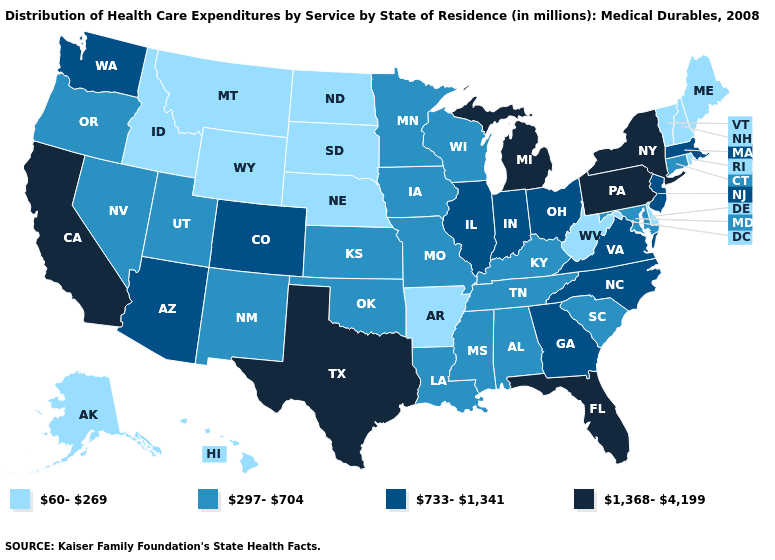Which states have the lowest value in the South?
Be succinct. Arkansas, Delaware, West Virginia. Name the states that have a value in the range 297-704?
Short answer required. Alabama, Connecticut, Iowa, Kansas, Kentucky, Louisiana, Maryland, Minnesota, Mississippi, Missouri, Nevada, New Mexico, Oklahoma, Oregon, South Carolina, Tennessee, Utah, Wisconsin. What is the value of Virginia?
Give a very brief answer. 733-1,341. Does Rhode Island have the same value as Connecticut?
Short answer required. No. Which states hav the highest value in the MidWest?
Write a very short answer. Michigan. Does Georgia have the lowest value in the South?
Be succinct. No. Among the states that border Missouri , does Tennessee have the highest value?
Quick response, please. No. What is the value of Alabama?
Short answer required. 297-704. Among the states that border Massachusetts , does New Hampshire have the lowest value?
Write a very short answer. Yes. What is the value of Idaho?
Short answer required. 60-269. What is the highest value in the USA?
Concise answer only. 1,368-4,199. Name the states that have a value in the range 733-1,341?
Quick response, please. Arizona, Colorado, Georgia, Illinois, Indiana, Massachusetts, New Jersey, North Carolina, Ohio, Virginia, Washington. Among the states that border Idaho , does Montana have the lowest value?
Short answer required. Yes. Name the states that have a value in the range 297-704?
Write a very short answer. Alabama, Connecticut, Iowa, Kansas, Kentucky, Louisiana, Maryland, Minnesota, Mississippi, Missouri, Nevada, New Mexico, Oklahoma, Oregon, South Carolina, Tennessee, Utah, Wisconsin. Among the states that border Georgia , which have the lowest value?
Keep it brief. Alabama, South Carolina, Tennessee. 